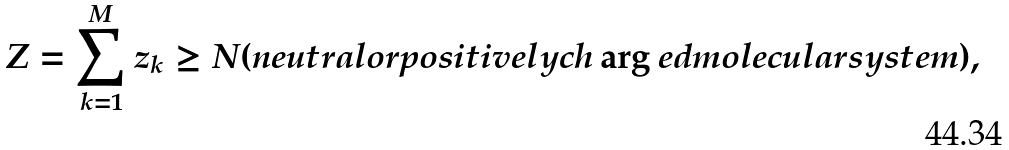<formula> <loc_0><loc_0><loc_500><loc_500>Z = \sum _ { k = 1 } ^ { M } z _ { k } \geq N ( n e u t r a l o r p o s i t i v e l y c h \arg e d m o l e c u l a r s y s t e m ) ,</formula> 